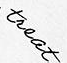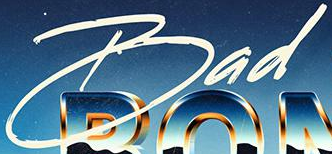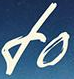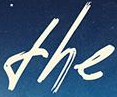What words are shown in these images in order, separated by a semicolon? treat; Bad; fo; the 